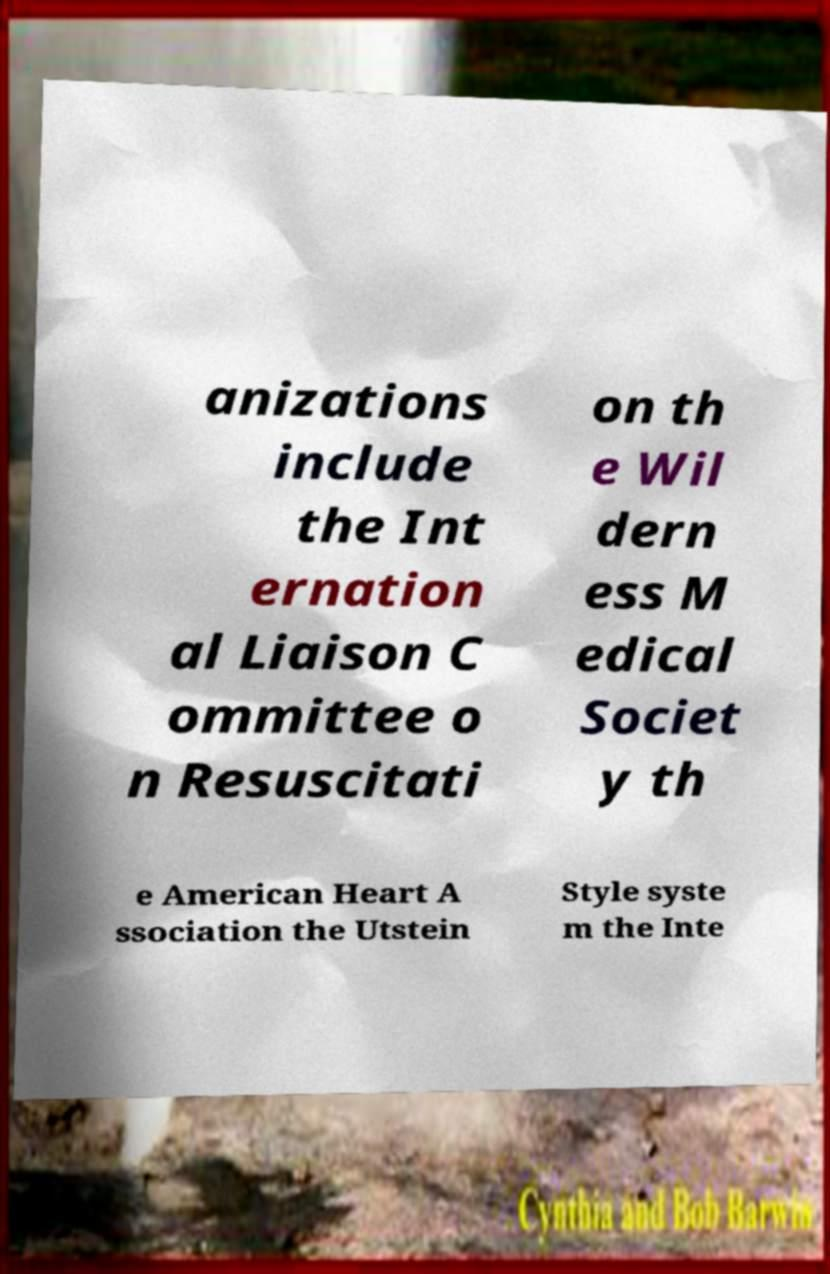Can you read and provide the text displayed in the image?This photo seems to have some interesting text. Can you extract and type it out for me? anizations include the Int ernation al Liaison C ommittee o n Resuscitati on th e Wil dern ess M edical Societ y th e American Heart A ssociation the Utstein Style syste m the Inte 